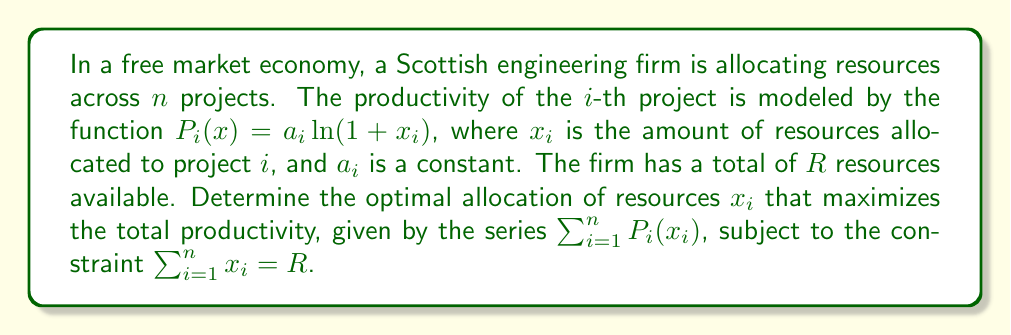Show me your answer to this math problem. To solve this optimization problem, we'll use the method of Lagrange multipliers:

1) Form the Lagrangian function:
   $$L(x_1, \ldots, x_n, \lambda) = \sum_{i=1}^n a_i\ln(1+x_i) - \lambda(\sum_{i=1}^n x_i - R)$$

2) Take partial derivatives with respect to each $x_i$ and $\lambda$:
   $$\frac{\partial L}{\partial x_i} = \frac{a_i}{1+x_i} - \lambda = 0$$
   $$\frac{\partial L}{\partial \lambda} = \sum_{i=1}^n x_i - R = 0$$

3) From the first equation:
   $$\frac{a_i}{1+x_i} = \lambda$$
   $$x_i = \frac{a_i}{\lambda} - 1$$

4) Substitute this into the constraint equation:
   $$\sum_{i=1}^n (\frac{a_i}{\lambda} - 1) = R$$
   $$\frac{1}{\lambda}\sum_{i=1}^n a_i - n = R$$
   $$\frac{1}{\lambda} = \frac{R+n}{\sum_{i=1}^n a_i}$$

5) Therefore, the optimal allocation for each project is:
   $$x_i = \frac{a_i(R+n)}{\sum_{j=1}^n a_j} - 1$$

This solution ensures that projects with higher productivity constants ($a_i$) receive more resources, while still allocating some resources to all projects.
Answer: $x_i = \frac{a_i(R+n)}{\sum_{j=1}^n a_j} - 1$ 